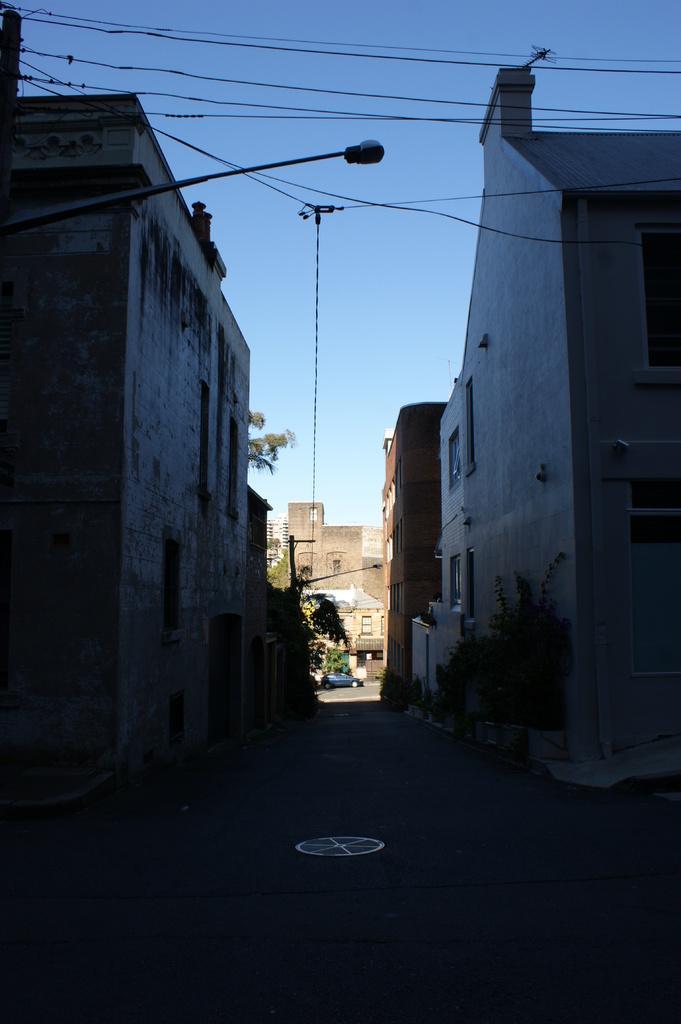Could you give a brief overview of what you see in this image? This image is clicked on the road. At the bottom, there is a road. On the left and right, there are buildings. In the background, we can see a car on the road along with a tree and a building. At the top, there is sky. And we can see the wires along with a light. 